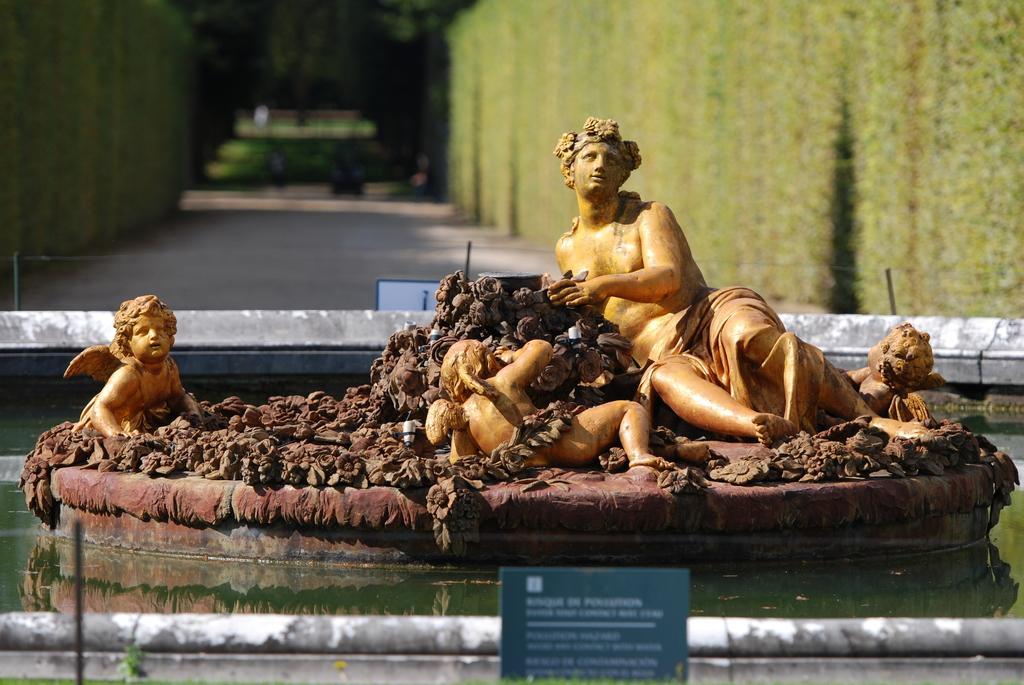Could you give a brief overview of what you see in this image? In the image I can see a path on which there are some statues and around there are some water and also I can see a board on which there is something written. 